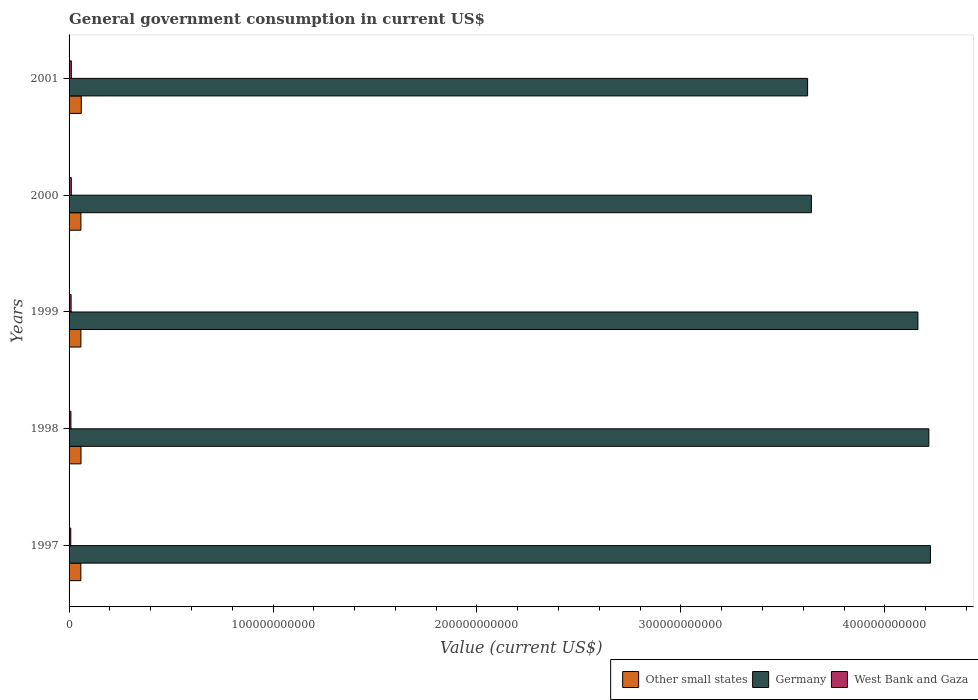How many groups of bars are there?
Offer a terse response. 5. How many bars are there on the 1st tick from the top?
Offer a terse response. 3. What is the label of the 2nd group of bars from the top?
Offer a very short reply. 2000. What is the government conusmption in Other small states in 2000?
Your response must be concise. 5.80e+09. Across all years, what is the maximum government conusmption in Germany?
Your response must be concise. 4.22e+11. Across all years, what is the minimum government conusmption in Other small states?
Give a very brief answer. 5.78e+09. What is the total government conusmption in Other small states in the graph?
Provide a succinct answer. 2.92e+1. What is the difference between the government conusmption in Other small states in 1997 and that in 2000?
Provide a succinct answer. -2.12e+07. What is the difference between the government conusmption in West Bank and Gaza in 1997 and the government conusmption in Germany in 2001?
Your answer should be compact. -3.61e+11. What is the average government conusmption in Other small states per year?
Your answer should be very brief. 5.84e+09. In the year 2001, what is the difference between the government conusmption in Other small states and government conusmption in Germany?
Provide a succinct answer. -3.56e+11. What is the ratio of the government conusmption in West Bank and Gaza in 1999 to that in 2000?
Offer a terse response. 0.91. Is the government conusmption in West Bank and Gaza in 1998 less than that in 2000?
Provide a short and direct response. Yes. Is the difference between the government conusmption in Other small states in 1997 and 2001 greater than the difference between the government conusmption in Germany in 1997 and 2001?
Offer a very short reply. No. What is the difference between the highest and the second highest government conusmption in West Bank and Gaza?
Your response must be concise. 1.79e+07. What is the difference between the highest and the lowest government conusmption in Germany?
Provide a short and direct response. 6.02e+1. In how many years, is the government conusmption in West Bank and Gaza greater than the average government conusmption in West Bank and Gaza taken over all years?
Ensure brevity in your answer.  3. What does the 1st bar from the top in 1997 represents?
Your answer should be compact. West Bank and Gaza. Is it the case that in every year, the sum of the government conusmption in Germany and government conusmption in Other small states is greater than the government conusmption in West Bank and Gaza?
Offer a terse response. Yes. How many bars are there?
Ensure brevity in your answer.  15. Are all the bars in the graph horizontal?
Offer a terse response. Yes. What is the difference between two consecutive major ticks on the X-axis?
Provide a short and direct response. 1.00e+11. Are the values on the major ticks of X-axis written in scientific E-notation?
Offer a terse response. No. Does the graph contain any zero values?
Offer a terse response. No. Where does the legend appear in the graph?
Your answer should be compact. Bottom right. How many legend labels are there?
Make the answer very short. 3. What is the title of the graph?
Your response must be concise. General government consumption in current US$. Does "Tunisia" appear as one of the legend labels in the graph?
Ensure brevity in your answer.  No. What is the label or title of the X-axis?
Keep it short and to the point. Value (current US$). What is the label or title of the Y-axis?
Ensure brevity in your answer.  Years. What is the Value (current US$) in Other small states in 1997?
Your response must be concise. 5.78e+09. What is the Value (current US$) in Germany in 1997?
Ensure brevity in your answer.  4.22e+11. What is the Value (current US$) of West Bank and Gaza in 1997?
Keep it short and to the point. 8.33e+08. What is the Value (current US$) in Other small states in 1998?
Keep it short and to the point. 5.85e+09. What is the Value (current US$) in Germany in 1998?
Make the answer very short. 4.22e+11. What is the Value (current US$) in West Bank and Gaza in 1998?
Your response must be concise. 9.07e+08. What is the Value (current US$) of Other small states in 1999?
Keep it short and to the point. 5.79e+09. What is the Value (current US$) of Germany in 1999?
Offer a very short reply. 4.16e+11. What is the Value (current US$) in West Bank and Gaza in 1999?
Give a very brief answer. 1.00e+09. What is the Value (current US$) of Other small states in 2000?
Keep it short and to the point. 5.80e+09. What is the Value (current US$) of Germany in 2000?
Provide a succinct answer. 3.64e+11. What is the Value (current US$) of West Bank and Gaza in 2000?
Ensure brevity in your answer.  1.10e+09. What is the Value (current US$) of Other small states in 2001?
Keep it short and to the point. 5.98e+09. What is the Value (current US$) in Germany in 2001?
Offer a very short reply. 3.62e+11. What is the Value (current US$) in West Bank and Gaza in 2001?
Your answer should be compact. 1.12e+09. Across all years, what is the maximum Value (current US$) of Other small states?
Offer a terse response. 5.98e+09. Across all years, what is the maximum Value (current US$) in Germany?
Your answer should be compact. 4.22e+11. Across all years, what is the maximum Value (current US$) of West Bank and Gaza?
Keep it short and to the point. 1.12e+09. Across all years, what is the minimum Value (current US$) of Other small states?
Offer a terse response. 5.78e+09. Across all years, what is the minimum Value (current US$) in Germany?
Ensure brevity in your answer.  3.62e+11. Across all years, what is the minimum Value (current US$) in West Bank and Gaza?
Offer a very short reply. 8.33e+08. What is the total Value (current US$) in Other small states in the graph?
Provide a succinct answer. 2.92e+1. What is the total Value (current US$) in Germany in the graph?
Ensure brevity in your answer.  1.99e+12. What is the total Value (current US$) of West Bank and Gaza in the graph?
Your answer should be very brief. 4.96e+09. What is the difference between the Value (current US$) of Other small states in 1997 and that in 1998?
Offer a terse response. -7.07e+07. What is the difference between the Value (current US$) in Germany in 1997 and that in 1998?
Provide a succinct answer. 7.65e+08. What is the difference between the Value (current US$) of West Bank and Gaza in 1997 and that in 1998?
Keep it short and to the point. -7.43e+07. What is the difference between the Value (current US$) of Other small states in 1997 and that in 1999?
Keep it short and to the point. -9.51e+06. What is the difference between the Value (current US$) of Germany in 1997 and that in 1999?
Provide a succinct answer. 6.14e+09. What is the difference between the Value (current US$) of West Bank and Gaza in 1997 and that in 1999?
Offer a terse response. -1.68e+08. What is the difference between the Value (current US$) in Other small states in 1997 and that in 2000?
Provide a short and direct response. -2.12e+07. What is the difference between the Value (current US$) in Germany in 1997 and that in 2000?
Make the answer very short. 5.84e+1. What is the difference between the Value (current US$) in West Bank and Gaza in 1997 and that in 2000?
Your answer should be compact. -2.67e+08. What is the difference between the Value (current US$) in Other small states in 1997 and that in 2001?
Offer a terse response. -2.05e+08. What is the difference between the Value (current US$) of Germany in 1997 and that in 2001?
Your answer should be very brief. 6.02e+1. What is the difference between the Value (current US$) of West Bank and Gaza in 1997 and that in 2001?
Ensure brevity in your answer.  -2.85e+08. What is the difference between the Value (current US$) of Other small states in 1998 and that in 1999?
Offer a very short reply. 6.12e+07. What is the difference between the Value (current US$) of Germany in 1998 and that in 1999?
Your response must be concise. 5.37e+09. What is the difference between the Value (current US$) of West Bank and Gaza in 1998 and that in 1999?
Offer a terse response. -9.39e+07. What is the difference between the Value (current US$) in Other small states in 1998 and that in 2000?
Your answer should be compact. 4.95e+07. What is the difference between the Value (current US$) of Germany in 1998 and that in 2000?
Provide a succinct answer. 5.76e+1. What is the difference between the Value (current US$) in West Bank and Gaza in 1998 and that in 2000?
Ensure brevity in your answer.  -1.93e+08. What is the difference between the Value (current US$) in Other small states in 1998 and that in 2001?
Your response must be concise. -1.34e+08. What is the difference between the Value (current US$) in Germany in 1998 and that in 2001?
Your response must be concise. 5.94e+1. What is the difference between the Value (current US$) of West Bank and Gaza in 1998 and that in 2001?
Offer a terse response. -2.10e+08. What is the difference between the Value (current US$) in Other small states in 1999 and that in 2000?
Offer a terse response. -1.17e+07. What is the difference between the Value (current US$) in Germany in 1999 and that in 2000?
Provide a short and direct response. 5.22e+1. What is the difference between the Value (current US$) of West Bank and Gaza in 1999 and that in 2000?
Offer a very short reply. -9.87e+07. What is the difference between the Value (current US$) of Other small states in 1999 and that in 2001?
Your response must be concise. -1.95e+08. What is the difference between the Value (current US$) in Germany in 1999 and that in 2001?
Offer a very short reply. 5.41e+1. What is the difference between the Value (current US$) of West Bank and Gaza in 1999 and that in 2001?
Your answer should be very brief. -1.17e+08. What is the difference between the Value (current US$) of Other small states in 2000 and that in 2001?
Make the answer very short. -1.84e+08. What is the difference between the Value (current US$) of Germany in 2000 and that in 2001?
Keep it short and to the point. 1.84e+09. What is the difference between the Value (current US$) in West Bank and Gaza in 2000 and that in 2001?
Make the answer very short. -1.79e+07. What is the difference between the Value (current US$) of Other small states in 1997 and the Value (current US$) of Germany in 1998?
Offer a very short reply. -4.16e+11. What is the difference between the Value (current US$) in Other small states in 1997 and the Value (current US$) in West Bank and Gaza in 1998?
Your answer should be very brief. 4.87e+09. What is the difference between the Value (current US$) in Germany in 1997 and the Value (current US$) in West Bank and Gaza in 1998?
Provide a short and direct response. 4.21e+11. What is the difference between the Value (current US$) in Other small states in 1997 and the Value (current US$) in Germany in 1999?
Offer a terse response. -4.10e+11. What is the difference between the Value (current US$) of Other small states in 1997 and the Value (current US$) of West Bank and Gaza in 1999?
Ensure brevity in your answer.  4.78e+09. What is the difference between the Value (current US$) in Germany in 1997 and the Value (current US$) in West Bank and Gaza in 1999?
Your answer should be very brief. 4.21e+11. What is the difference between the Value (current US$) of Other small states in 1997 and the Value (current US$) of Germany in 2000?
Keep it short and to the point. -3.58e+11. What is the difference between the Value (current US$) of Other small states in 1997 and the Value (current US$) of West Bank and Gaza in 2000?
Offer a very short reply. 4.68e+09. What is the difference between the Value (current US$) of Germany in 1997 and the Value (current US$) of West Bank and Gaza in 2000?
Your answer should be compact. 4.21e+11. What is the difference between the Value (current US$) of Other small states in 1997 and the Value (current US$) of Germany in 2001?
Ensure brevity in your answer.  -3.56e+11. What is the difference between the Value (current US$) of Other small states in 1997 and the Value (current US$) of West Bank and Gaza in 2001?
Your response must be concise. 4.66e+09. What is the difference between the Value (current US$) of Germany in 1997 and the Value (current US$) of West Bank and Gaza in 2001?
Your answer should be compact. 4.21e+11. What is the difference between the Value (current US$) in Other small states in 1998 and the Value (current US$) in Germany in 1999?
Your answer should be compact. -4.10e+11. What is the difference between the Value (current US$) of Other small states in 1998 and the Value (current US$) of West Bank and Gaza in 1999?
Ensure brevity in your answer.  4.85e+09. What is the difference between the Value (current US$) in Germany in 1998 and the Value (current US$) in West Bank and Gaza in 1999?
Ensure brevity in your answer.  4.21e+11. What is the difference between the Value (current US$) in Other small states in 1998 and the Value (current US$) in Germany in 2000?
Offer a very short reply. -3.58e+11. What is the difference between the Value (current US$) of Other small states in 1998 and the Value (current US$) of West Bank and Gaza in 2000?
Your answer should be compact. 4.75e+09. What is the difference between the Value (current US$) in Germany in 1998 and the Value (current US$) in West Bank and Gaza in 2000?
Offer a terse response. 4.20e+11. What is the difference between the Value (current US$) in Other small states in 1998 and the Value (current US$) in Germany in 2001?
Make the answer very short. -3.56e+11. What is the difference between the Value (current US$) of Other small states in 1998 and the Value (current US$) of West Bank and Gaza in 2001?
Your answer should be very brief. 4.73e+09. What is the difference between the Value (current US$) in Germany in 1998 and the Value (current US$) in West Bank and Gaza in 2001?
Your answer should be compact. 4.20e+11. What is the difference between the Value (current US$) in Other small states in 1999 and the Value (current US$) in Germany in 2000?
Provide a succinct answer. -3.58e+11. What is the difference between the Value (current US$) in Other small states in 1999 and the Value (current US$) in West Bank and Gaza in 2000?
Provide a succinct answer. 4.69e+09. What is the difference between the Value (current US$) in Germany in 1999 and the Value (current US$) in West Bank and Gaza in 2000?
Your response must be concise. 4.15e+11. What is the difference between the Value (current US$) of Other small states in 1999 and the Value (current US$) of Germany in 2001?
Offer a terse response. -3.56e+11. What is the difference between the Value (current US$) of Other small states in 1999 and the Value (current US$) of West Bank and Gaza in 2001?
Offer a terse response. 4.67e+09. What is the difference between the Value (current US$) in Germany in 1999 and the Value (current US$) in West Bank and Gaza in 2001?
Provide a succinct answer. 4.15e+11. What is the difference between the Value (current US$) in Other small states in 2000 and the Value (current US$) in Germany in 2001?
Offer a very short reply. -3.56e+11. What is the difference between the Value (current US$) of Other small states in 2000 and the Value (current US$) of West Bank and Gaza in 2001?
Ensure brevity in your answer.  4.68e+09. What is the difference between the Value (current US$) in Germany in 2000 and the Value (current US$) in West Bank and Gaza in 2001?
Offer a very short reply. 3.63e+11. What is the average Value (current US$) of Other small states per year?
Offer a very short reply. 5.84e+09. What is the average Value (current US$) of Germany per year?
Offer a very short reply. 3.97e+11. What is the average Value (current US$) of West Bank and Gaza per year?
Keep it short and to the point. 9.92e+08. In the year 1997, what is the difference between the Value (current US$) of Other small states and Value (current US$) of Germany?
Offer a very short reply. -4.17e+11. In the year 1997, what is the difference between the Value (current US$) in Other small states and Value (current US$) in West Bank and Gaza?
Give a very brief answer. 4.95e+09. In the year 1997, what is the difference between the Value (current US$) of Germany and Value (current US$) of West Bank and Gaza?
Provide a short and direct response. 4.21e+11. In the year 1998, what is the difference between the Value (current US$) in Other small states and Value (current US$) in Germany?
Make the answer very short. -4.16e+11. In the year 1998, what is the difference between the Value (current US$) of Other small states and Value (current US$) of West Bank and Gaza?
Give a very brief answer. 4.94e+09. In the year 1998, what is the difference between the Value (current US$) of Germany and Value (current US$) of West Bank and Gaza?
Provide a short and direct response. 4.21e+11. In the year 1999, what is the difference between the Value (current US$) of Other small states and Value (current US$) of Germany?
Make the answer very short. -4.10e+11. In the year 1999, what is the difference between the Value (current US$) in Other small states and Value (current US$) in West Bank and Gaza?
Provide a short and direct response. 4.79e+09. In the year 1999, what is the difference between the Value (current US$) of Germany and Value (current US$) of West Bank and Gaza?
Ensure brevity in your answer.  4.15e+11. In the year 2000, what is the difference between the Value (current US$) of Other small states and Value (current US$) of Germany?
Ensure brevity in your answer.  -3.58e+11. In the year 2000, what is the difference between the Value (current US$) of Other small states and Value (current US$) of West Bank and Gaza?
Provide a succinct answer. 4.70e+09. In the year 2000, what is the difference between the Value (current US$) of Germany and Value (current US$) of West Bank and Gaza?
Offer a terse response. 3.63e+11. In the year 2001, what is the difference between the Value (current US$) of Other small states and Value (current US$) of Germany?
Give a very brief answer. -3.56e+11. In the year 2001, what is the difference between the Value (current US$) of Other small states and Value (current US$) of West Bank and Gaza?
Offer a very short reply. 4.87e+09. In the year 2001, what is the difference between the Value (current US$) in Germany and Value (current US$) in West Bank and Gaza?
Your answer should be compact. 3.61e+11. What is the ratio of the Value (current US$) in Other small states in 1997 to that in 1998?
Your answer should be very brief. 0.99. What is the ratio of the Value (current US$) in West Bank and Gaza in 1997 to that in 1998?
Your answer should be very brief. 0.92. What is the ratio of the Value (current US$) in Other small states in 1997 to that in 1999?
Provide a succinct answer. 1. What is the ratio of the Value (current US$) in Germany in 1997 to that in 1999?
Your answer should be compact. 1.01. What is the ratio of the Value (current US$) of West Bank and Gaza in 1997 to that in 1999?
Your response must be concise. 0.83. What is the ratio of the Value (current US$) of Other small states in 1997 to that in 2000?
Keep it short and to the point. 1. What is the ratio of the Value (current US$) in Germany in 1997 to that in 2000?
Provide a short and direct response. 1.16. What is the ratio of the Value (current US$) in West Bank and Gaza in 1997 to that in 2000?
Keep it short and to the point. 0.76. What is the ratio of the Value (current US$) in Other small states in 1997 to that in 2001?
Make the answer very short. 0.97. What is the ratio of the Value (current US$) of Germany in 1997 to that in 2001?
Your answer should be very brief. 1.17. What is the ratio of the Value (current US$) of West Bank and Gaza in 1997 to that in 2001?
Ensure brevity in your answer.  0.75. What is the ratio of the Value (current US$) in Other small states in 1998 to that in 1999?
Provide a succinct answer. 1.01. What is the ratio of the Value (current US$) in Germany in 1998 to that in 1999?
Your response must be concise. 1.01. What is the ratio of the Value (current US$) in West Bank and Gaza in 1998 to that in 1999?
Make the answer very short. 0.91. What is the ratio of the Value (current US$) in Other small states in 1998 to that in 2000?
Your answer should be compact. 1.01. What is the ratio of the Value (current US$) in Germany in 1998 to that in 2000?
Your response must be concise. 1.16. What is the ratio of the Value (current US$) in West Bank and Gaza in 1998 to that in 2000?
Your answer should be very brief. 0.82. What is the ratio of the Value (current US$) in Other small states in 1998 to that in 2001?
Make the answer very short. 0.98. What is the ratio of the Value (current US$) of Germany in 1998 to that in 2001?
Keep it short and to the point. 1.16. What is the ratio of the Value (current US$) of West Bank and Gaza in 1998 to that in 2001?
Give a very brief answer. 0.81. What is the ratio of the Value (current US$) in Other small states in 1999 to that in 2000?
Make the answer very short. 1. What is the ratio of the Value (current US$) in Germany in 1999 to that in 2000?
Make the answer very short. 1.14. What is the ratio of the Value (current US$) of West Bank and Gaza in 1999 to that in 2000?
Your answer should be compact. 0.91. What is the ratio of the Value (current US$) of Other small states in 1999 to that in 2001?
Your answer should be compact. 0.97. What is the ratio of the Value (current US$) of Germany in 1999 to that in 2001?
Offer a very short reply. 1.15. What is the ratio of the Value (current US$) of West Bank and Gaza in 1999 to that in 2001?
Keep it short and to the point. 0.9. What is the ratio of the Value (current US$) in Other small states in 2000 to that in 2001?
Keep it short and to the point. 0.97. What is the ratio of the Value (current US$) in West Bank and Gaza in 2000 to that in 2001?
Your response must be concise. 0.98. What is the difference between the highest and the second highest Value (current US$) in Other small states?
Offer a very short reply. 1.34e+08. What is the difference between the highest and the second highest Value (current US$) in Germany?
Your answer should be compact. 7.65e+08. What is the difference between the highest and the second highest Value (current US$) in West Bank and Gaza?
Offer a very short reply. 1.79e+07. What is the difference between the highest and the lowest Value (current US$) in Other small states?
Provide a short and direct response. 2.05e+08. What is the difference between the highest and the lowest Value (current US$) of Germany?
Provide a succinct answer. 6.02e+1. What is the difference between the highest and the lowest Value (current US$) of West Bank and Gaza?
Keep it short and to the point. 2.85e+08. 